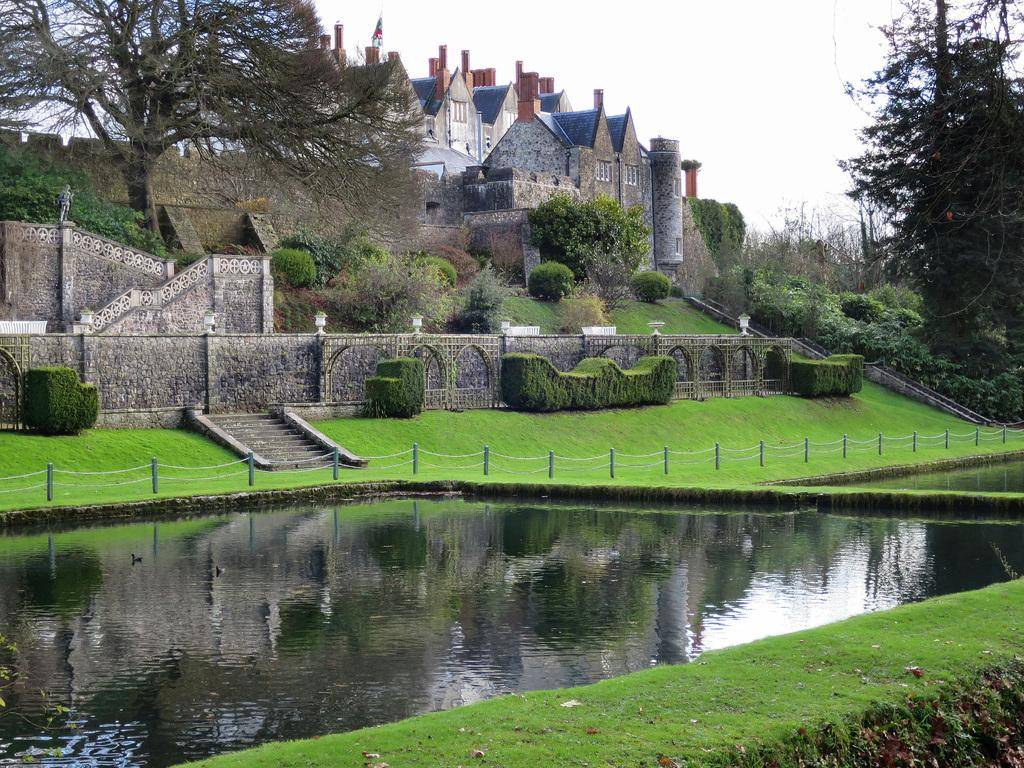What type of structures can be seen in the image? There are buildings in the image. What type of vegetation is present in the image? There are trees, plants, and grass in the image. What type of landscaping elements are present in the image contain? There are hedges and a fence in the image. What type of lighting is present in the image? There are lights on a compound wall in the image. What type of architectural feature is present in the image? There is a stairway in the image. What type of natural element is visible in the image? There is water visible in the image. What can be seen in the background of the image? The sky is visible in the background of the image. What is the purpose of the button in the image? There is no button present in the image. How does the rest of the landscape affect the overall aesthetic of the image? The question assumes the presence of a landscape, but the image does not contain a landscape. Instead, it contains various elements such as buildings, trees, plants, hedges, lights, a stairway, grass, a fence, water, and the sky. 